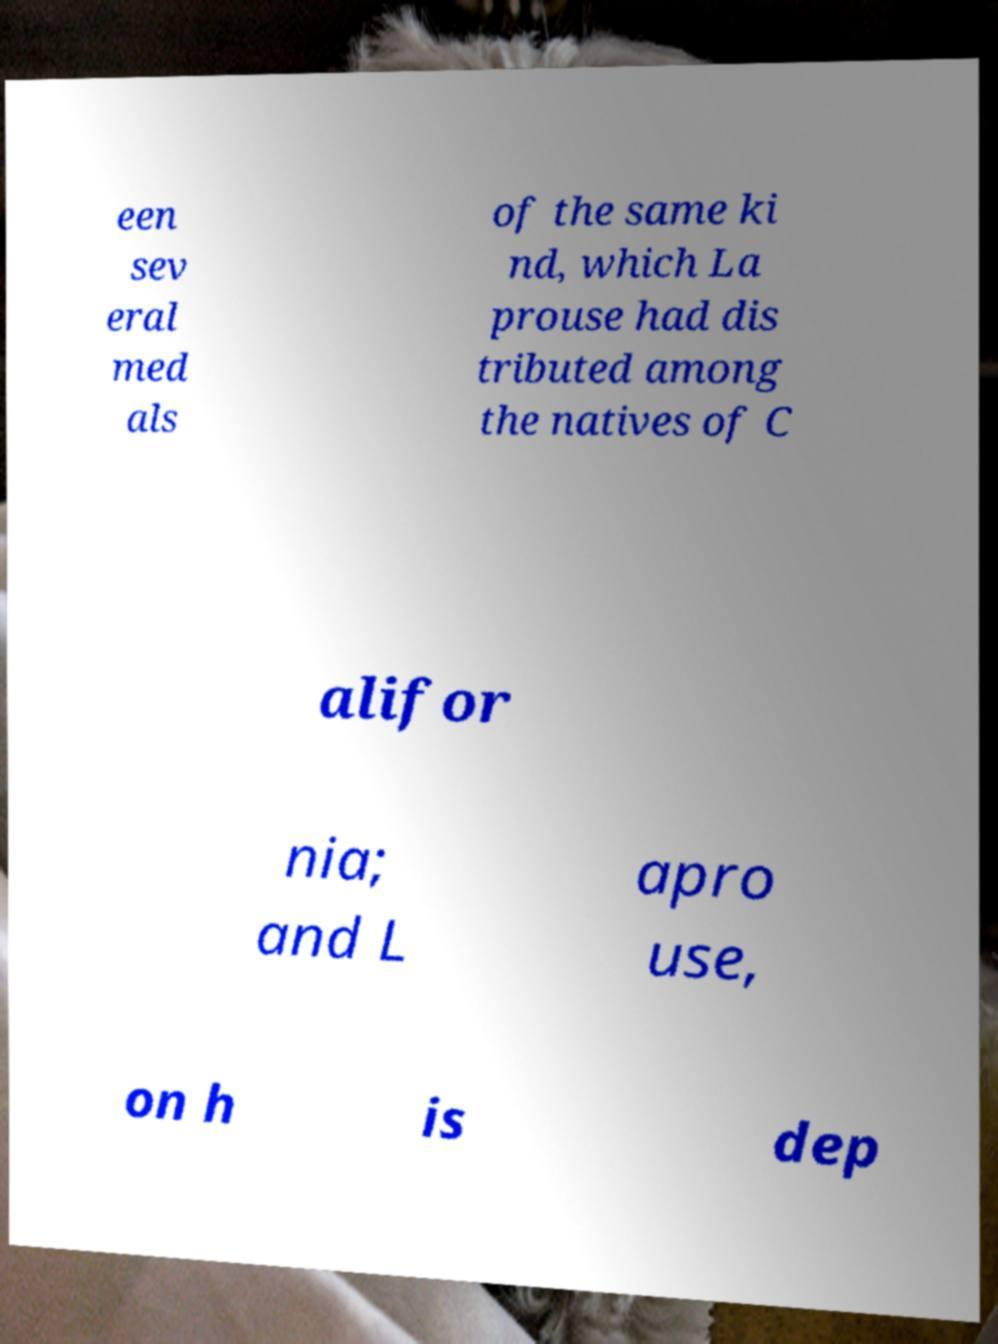Can you accurately transcribe the text from the provided image for me? een sev eral med als of the same ki nd, which La prouse had dis tributed among the natives of C alifor nia; and L apro use, on h is dep 